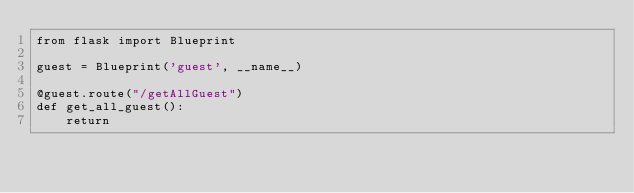Convert code to text. <code><loc_0><loc_0><loc_500><loc_500><_Python_>from flask import Blueprint

guest = Blueprint('guest', __name__)

@guest.route("/getAllGuest")
def get_all_guest():
    return</code> 